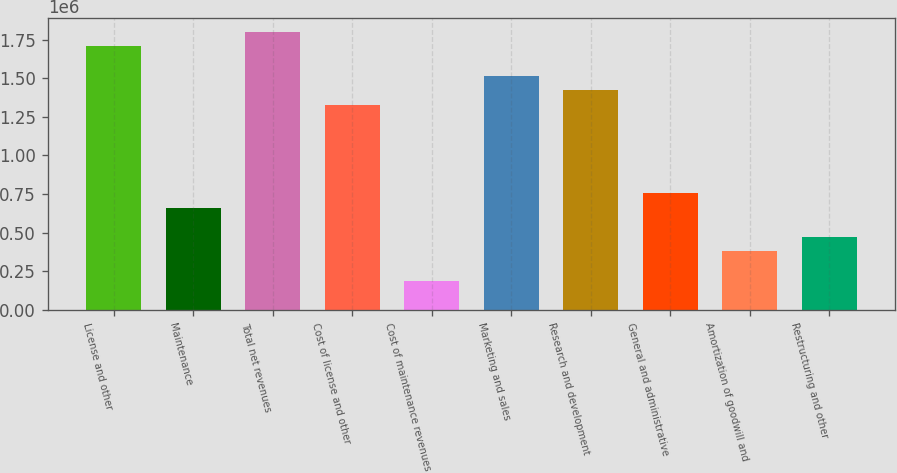Convert chart. <chart><loc_0><loc_0><loc_500><loc_500><bar_chart><fcel>License and other<fcel>Maintenance<fcel>Total net revenues<fcel>Cost of license and other<fcel>Cost of maintenance revenues<fcel>Marketing and sales<fcel>Research and development<fcel>General and administrative<fcel>Amortization of goodwill and<fcel>Restructuring and other<nl><fcel>1.70548e+06<fcel>663244<fcel>1.80023e+06<fcel>1.32649e+06<fcel>189499<fcel>1.51599e+06<fcel>1.42124e+06<fcel>757993<fcel>378997<fcel>473746<nl></chart> 